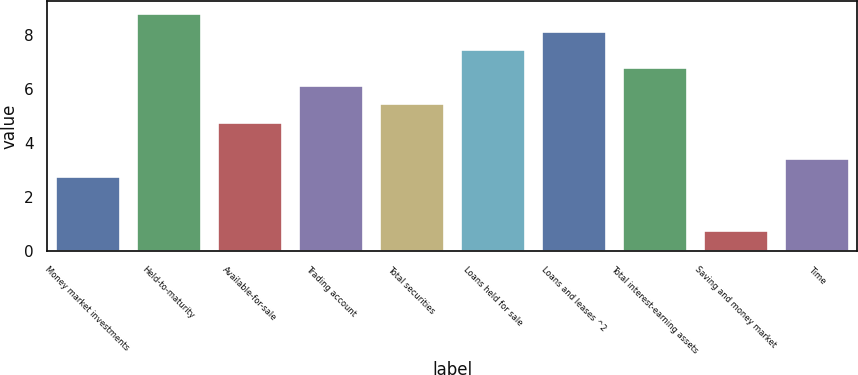<chart> <loc_0><loc_0><loc_500><loc_500><bar_chart><fcel>Money market investments<fcel>Held-to-maturity<fcel>Available-for-sale<fcel>Trading account<fcel>Total securities<fcel>Loans held for sale<fcel>Loans and leases ^2<fcel>Total interest-earning assets<fcel>Saving and money market<fcel>Time<nl><fcel>2.79<fcel>8.82<fcel>4.8<fcel>6.14<fcel>5.47<fcel>7.48<fcel>8.15<fcel>6.81<fcel>0.78<fcel>3.46<nl></chart> 